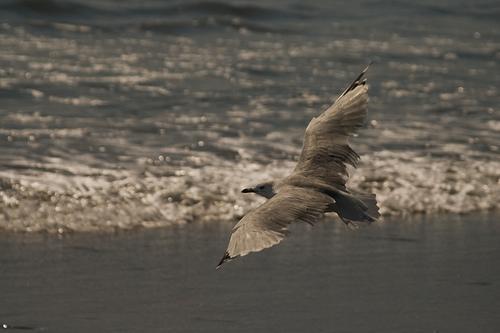How many birds are there?
Give a very brief answer. 1. 